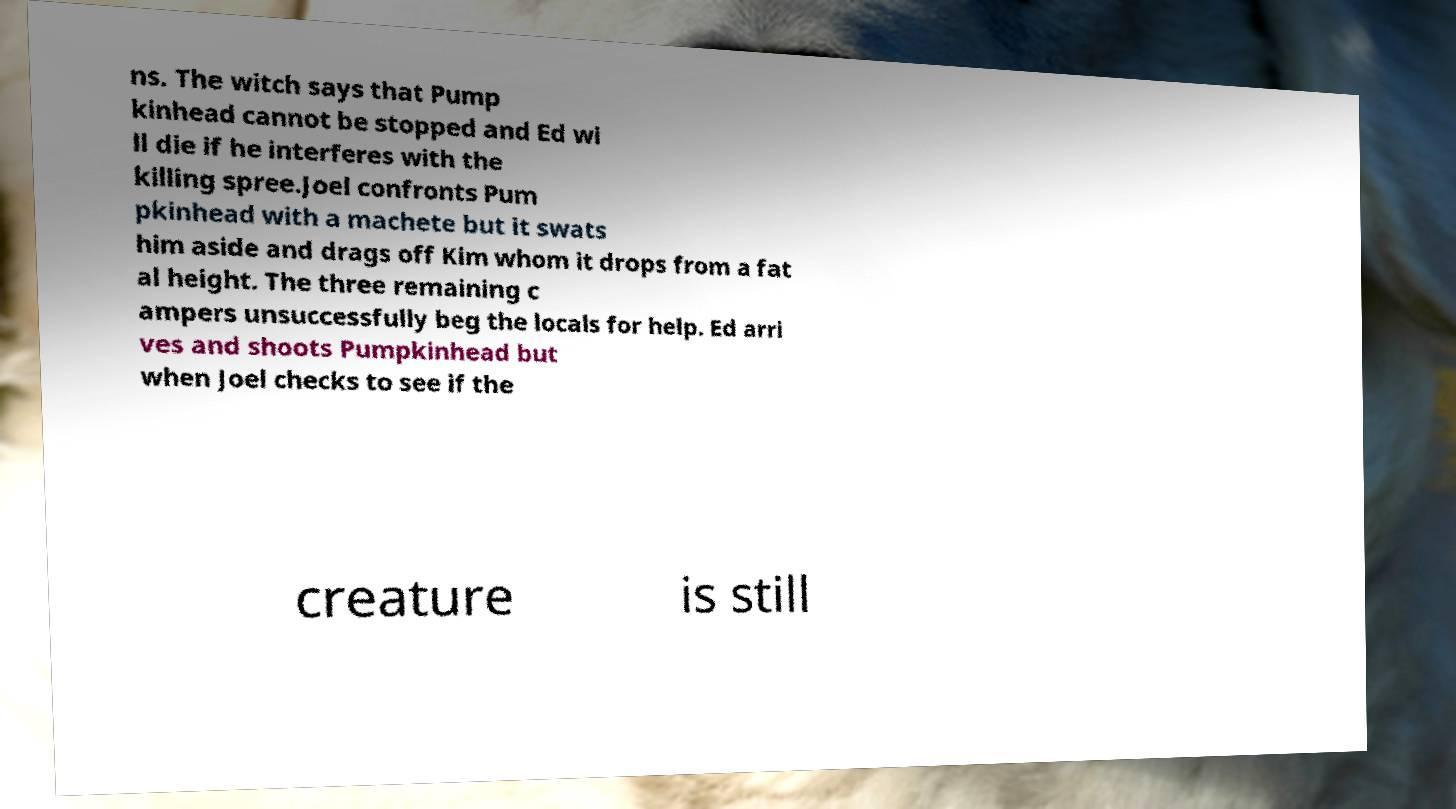Could you extract and type out the text from this image? ns. The witch says that Pump kinhead cannot be stopped and Ed wi ll die if he interferes with the killing spree.Joel confronts Pum pkinhead with a machete but it swats him aside and drags off Kim whom it drops from a fat al height. The three remaining c ampers unsuccessfully beg the locals for help. Ed arri ves and shoots Pumpkinhead but when Joel checks to see if the creature is still 